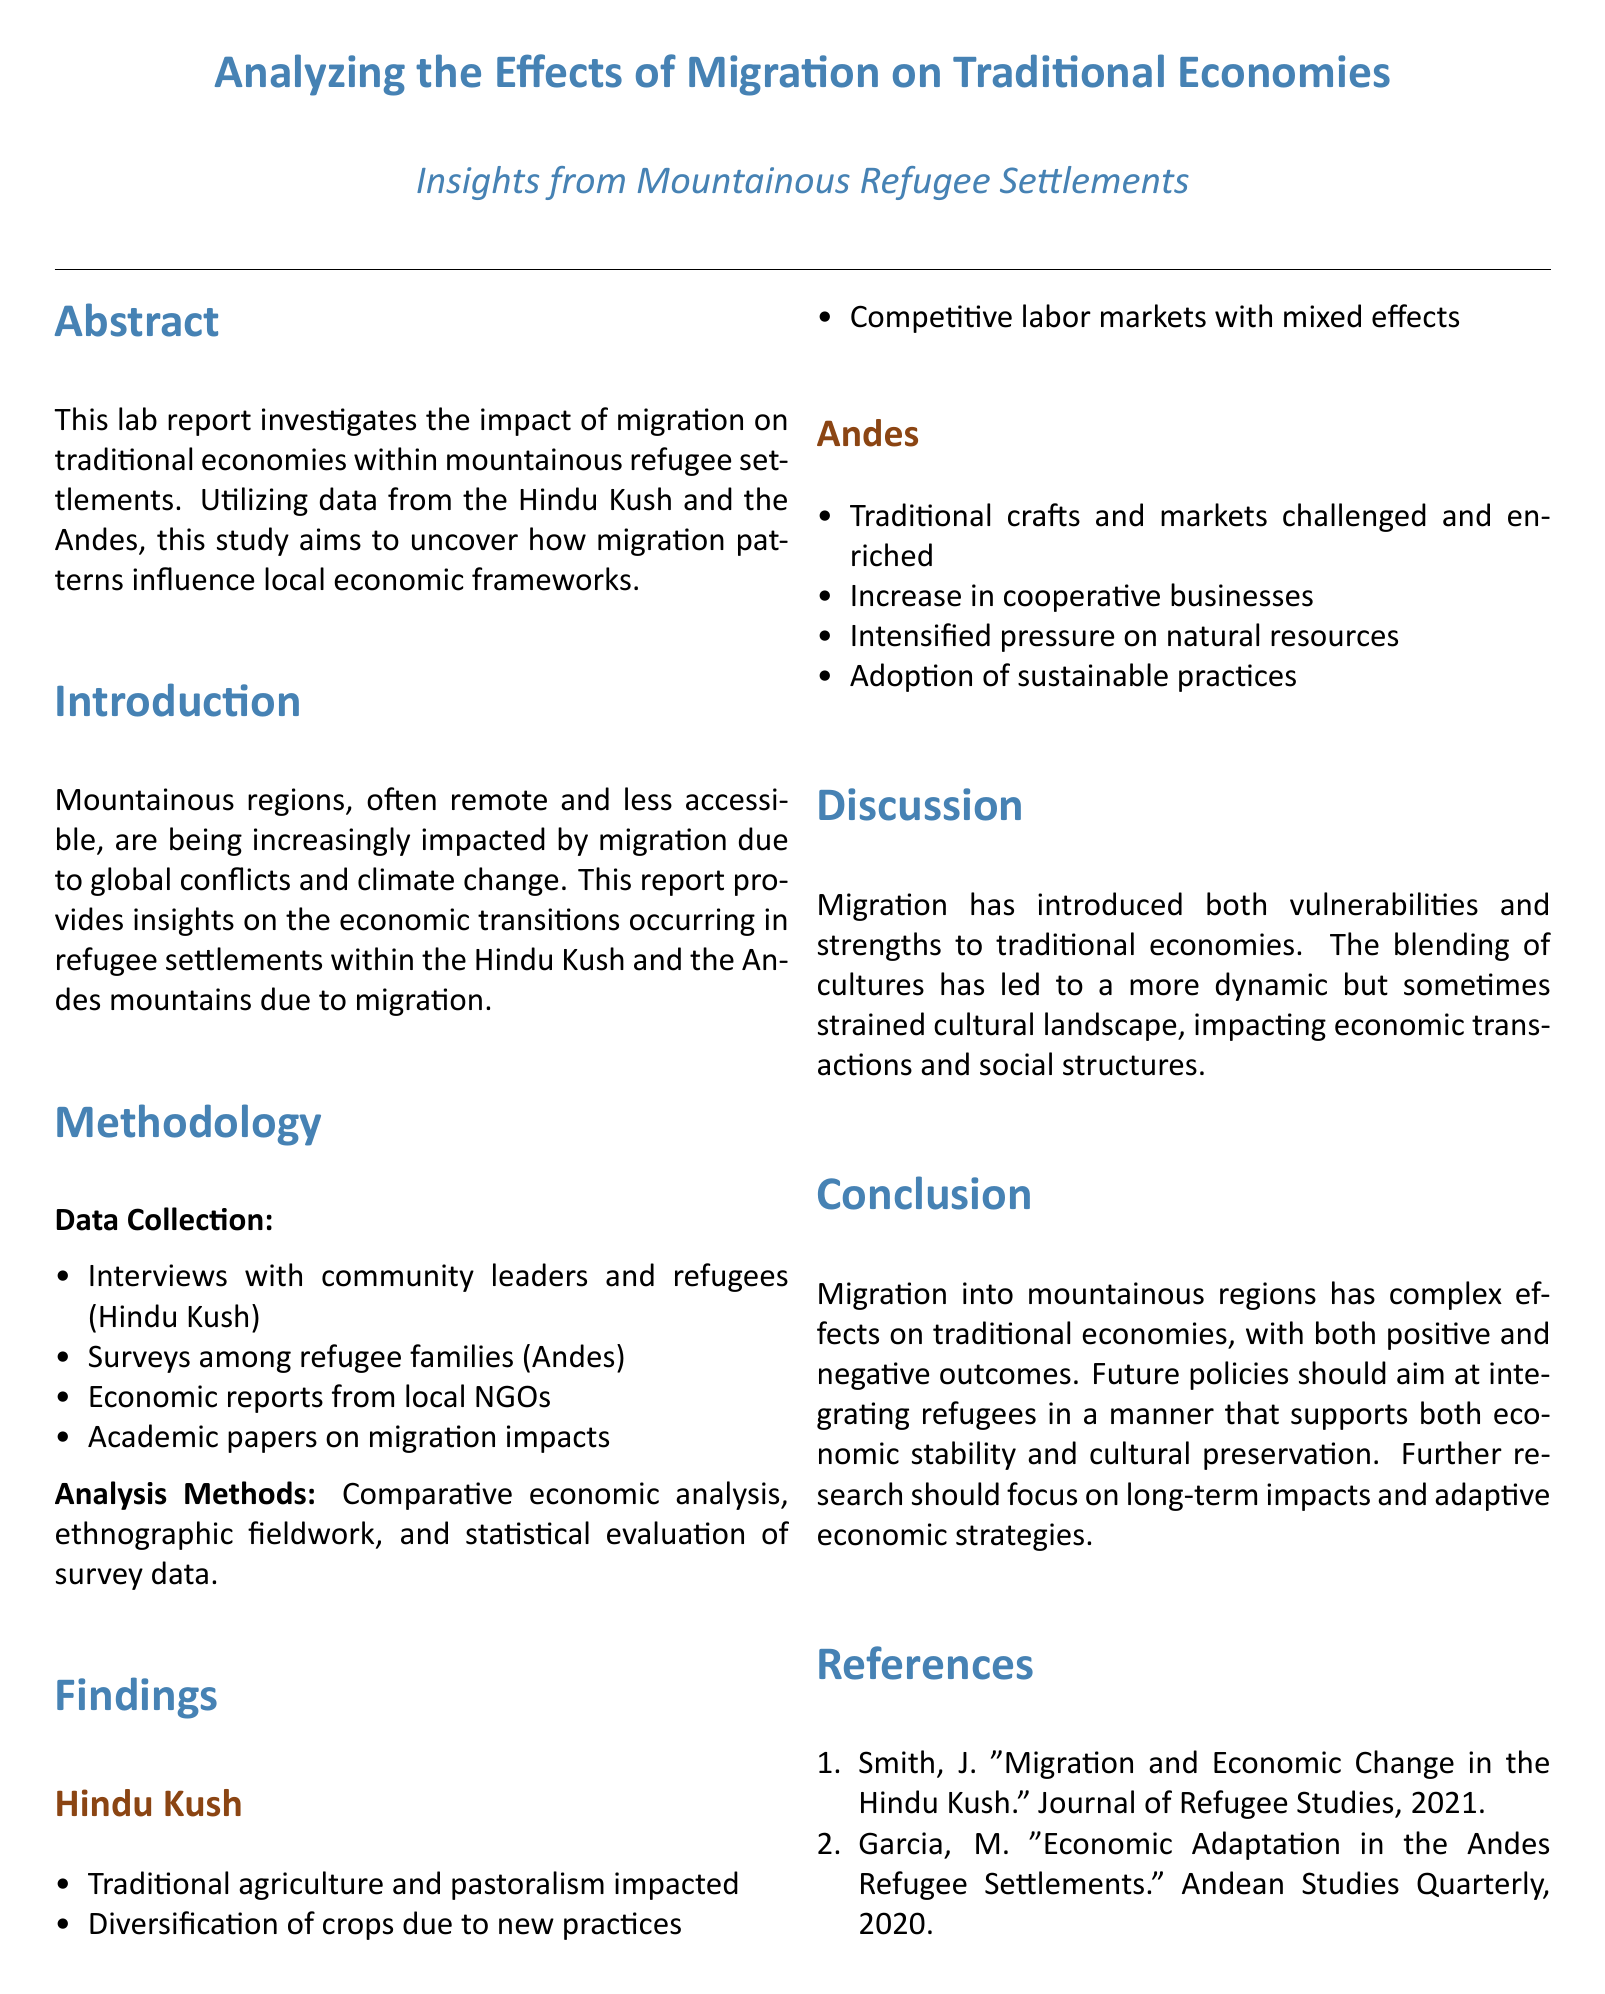What regions are studied in the report? The report investigates the impact of migration on traditional economies within mountainous refugee settlements in the Hindu Kush and the Andes.
Answer: Hindu Kush and Andes What is the main research method employed for data collection? The main data collection method involves interviews with community leaders and refugees, surveys among families, economic reports, and academic papers.
Answer: Interviews What are the findings related to agriculture in the Hindu Kush? The findings indicate that traditional agriculture and pastoralism are impacted, with diversification of crops due to new practices.
Answer: Impacted How have traditional crafts been affected in the Andes? The report notes that traditional crafts and markets have been both challenged and enriched.
Answer: Challenged and enriched What pressure has increased in the Andes due to migration? The analysis indicates intensified pressure on natural resources resulting from migration.
Answer: Natural resources What is the main conclusion of the report? The conclusion emphasizes that migration has complex effects on traditional economies with both positive and negative outcomes.
Answer: Complex effects What types of businesses have seen an increase in the Andes? The report mentions an increase in cooperative businesses as a result of migration.
Answer: Cooperative businesses What is the purpose of future research suggested in the conclusion? The report suggests that future research should focus on long-term impacts and adaptive economic strategies in refugee settlements.
Answer: Long-term impacts 